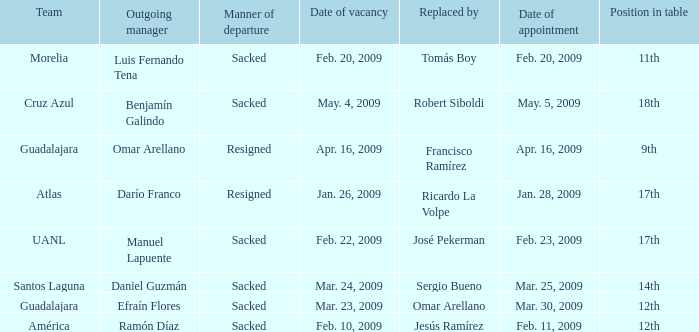What is Position in Table, when Replaced By is "Sergio Bueno"? 14th. 